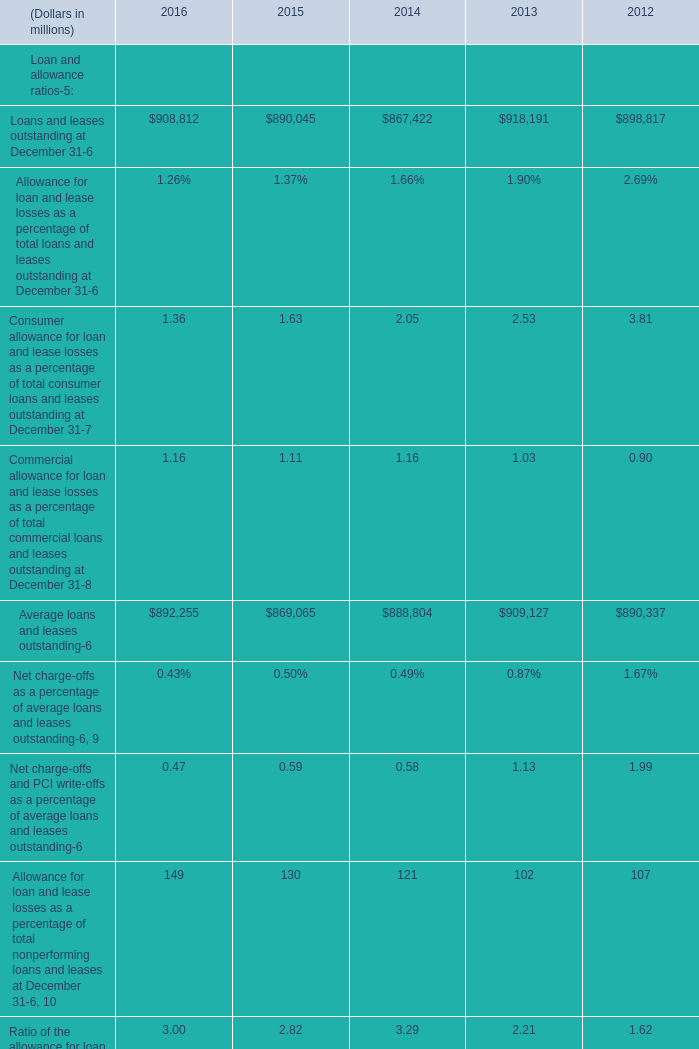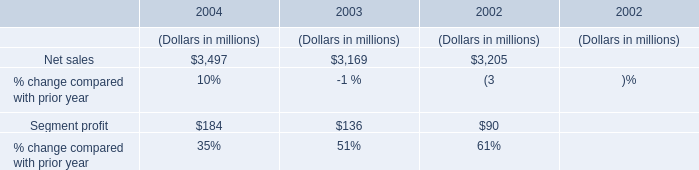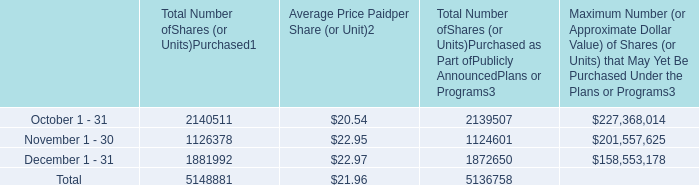what is the total cash used for the repurchase of shares during the last three months of the year , ( in millions ) ? 
Computations: ((5148881 * 21.96) / 1000000)
Answer: 113.06943. 